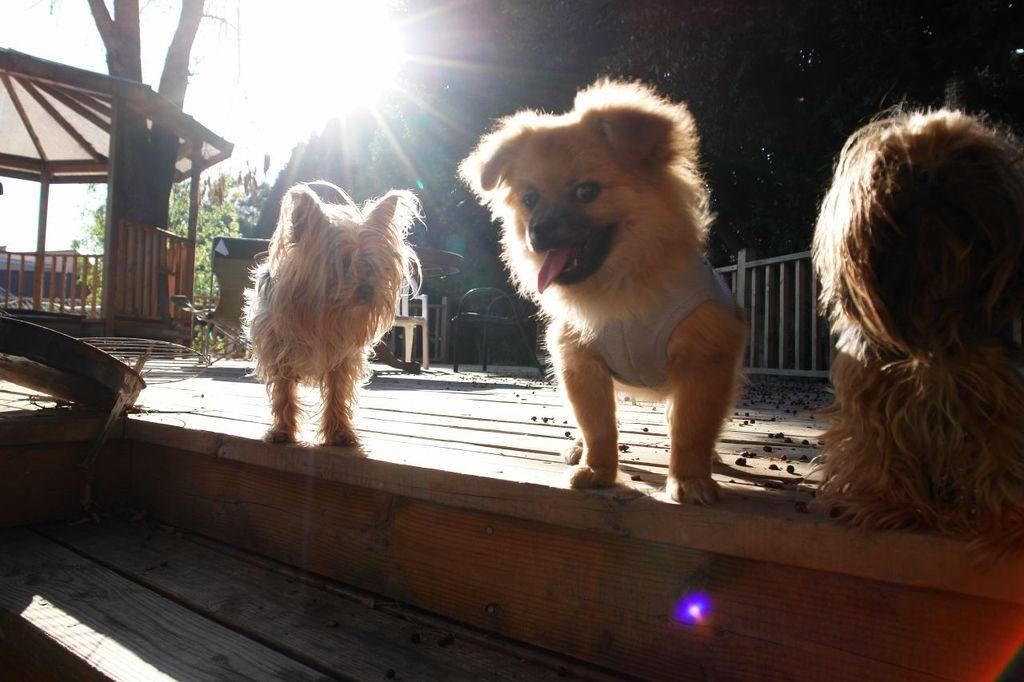How many dogs are in the image? There are three small brown dogs in the image. What are the dogs standing on? The dogs are standing on wooden steps. What can be seen in the background of the image? There is a fencing railing and a roof shed in the background of the image. What is the condition of the sky in the image? The sky is dark in the image. Is there any source of light visible in the image? Yes, there is light visible in the image. What type of breakfast is the dogs eating in the image? There is no breakfast present in the image; it features three small brown dogs standing on wooden steps. What achievement did the dogs accomplish to be recognized in the image? There is no indication of any achievement or recognition in the image; it simply shows three small brown dogs standing on wooden steps. 